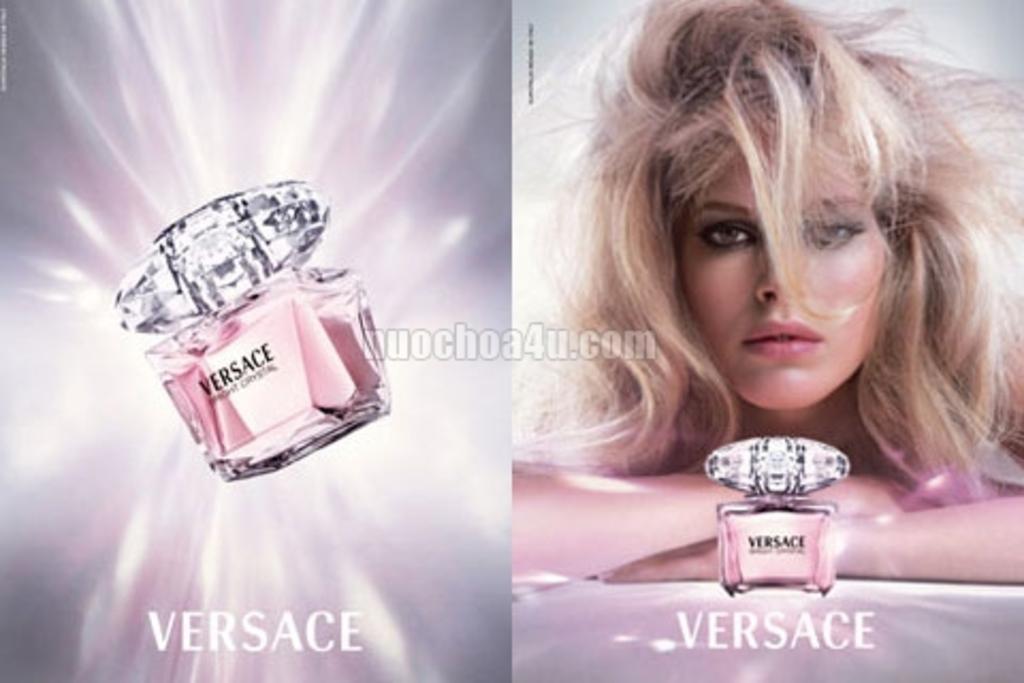Please provide a concise description of this image. This is a collage image. I can see a woman and there are perfume bottles. In the center of the image, I can see a watermark. At the bottom of the image, I can see the words. 